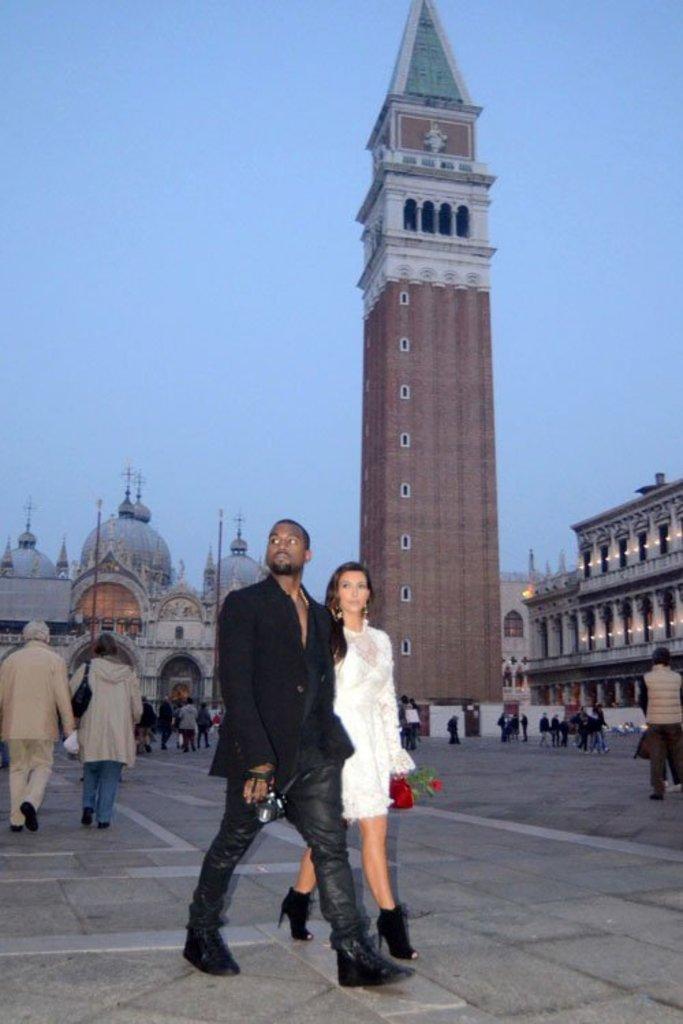Could you give a brief overview of what you see in this image? In this image, we can see a woman and man are walking on the path. Background we can see buildings, people, tower, poles, walls, pillars, lights, few objects and sky. 